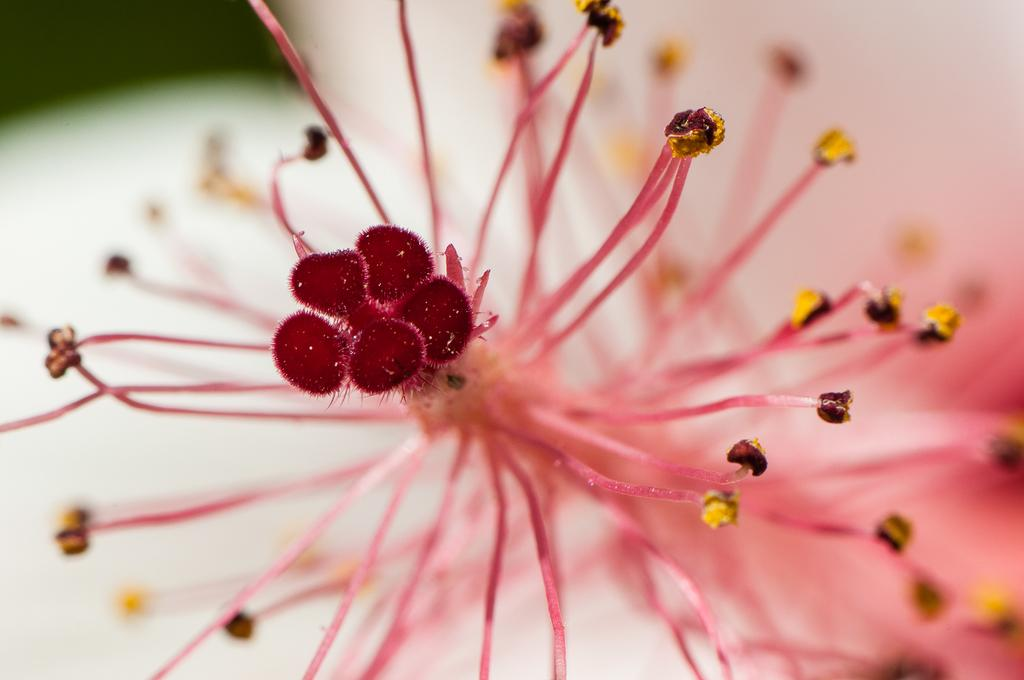What is the main subject of the image? There is a flower in the image. What are the reproductive parts of the flower? The flower has stamens and a stigma. How would you describe the background of the image? The background of the image is blurred. What type of texture can be seen on the land in the image? There is no land visible in the image; it features a flower with a blurred background. 